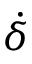Convert formula to latex. <formula><loc_0><loc_0><loc_500><loc_500>\dot { \delta }</formula> 